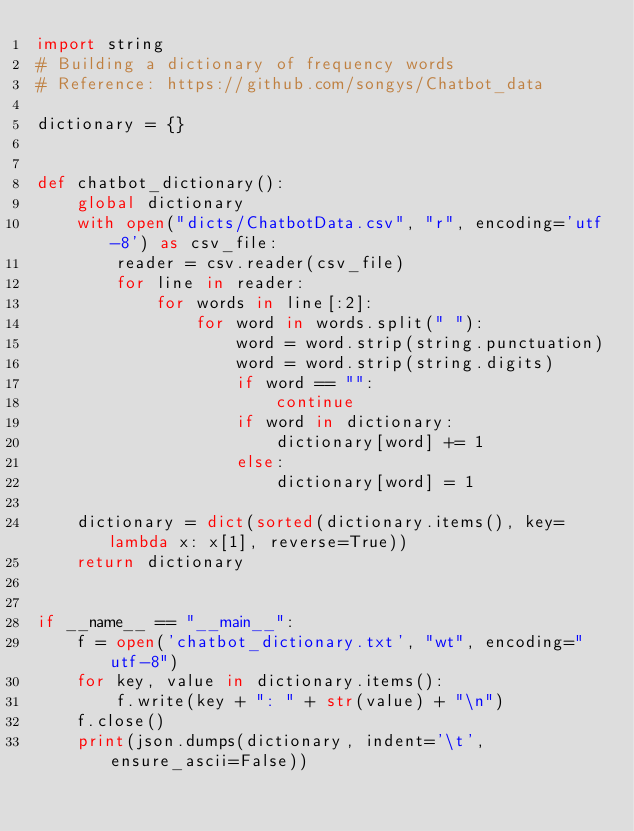<code> <loc_0><loc_0><loc_500><loc_500><_Python_>import string
# Building a dictionary of frequency words
# Reference: https://github.com/songys/Chatbot_data

dictionary = {}


def chatbot_dictionary():
    global dictionary
    with open("dicts/ChatbotData.csv", "r", encoding='utf-8') as csv_file:
        reader = csv.reader(csv_file)
        for line in reader:
            for words in line[:2]:
                for word in words.split(" "):
                    word = word.strip(string.punctuation)
                    word = word.strip(string.digits)
                    if word == "":
                        continue
                    if word in dictionary:
                        dictionary[word] += 1
                    else:
                        dictionary[word] = 1

    dictionary = dict(sorted(dictionary.items(), key=lambda x: x[1], reverse=True))
    return dictionary


if __name__ == "__main__":
    f = open('chatbot_dictionary.txt', "wt", encoding="utf-8")
    for key, value in dictionary.items():
        f.write(key + ": " + str(value) + "\n")
    f.close()
    print(json.dumps(dictionary, indent='\t', ensure_ascii=False))
</code> 